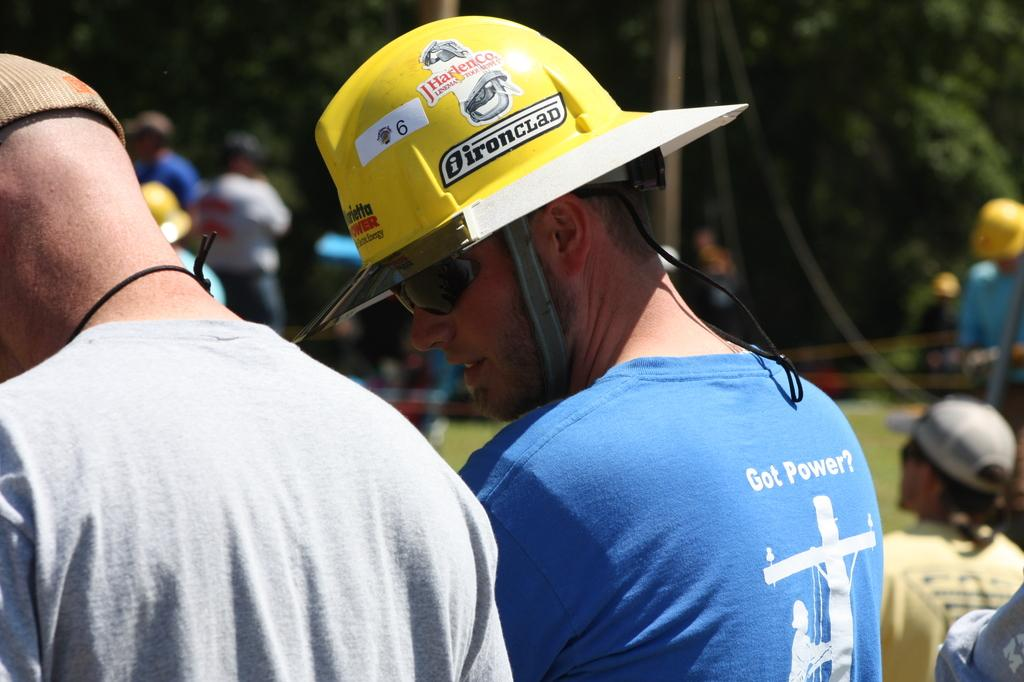How many people are present in the image? There are two persons in the image. What is the person on the left wearing? The person on the left is wearing a helmet and spectacles. What can be seen in the background of the image? There is a group of people and trees in the background of the image. What type of quilt is being used to cover the room in the image? There is no quilt or room present in the image; it features two persons and a background with a group of people and trees. 